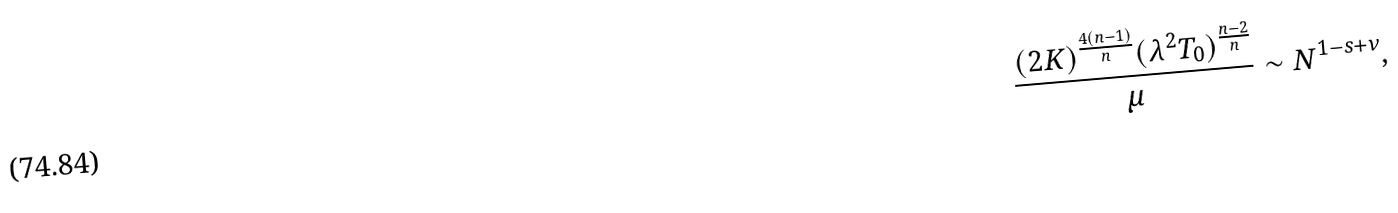Convert formula to latex. <formula><loc_0><loc_0><loc_500><loc_500>\frac { ( 2 K ) ^ { \frac { 4 ( n - 1 ) } { n } } ( \lambda ^ { 2 } T _ { 0 } ) ^ { \frac { n - 2 } { n } } } { \mu } \sim N ^ { 1 - s + \nu } ,</formula> 